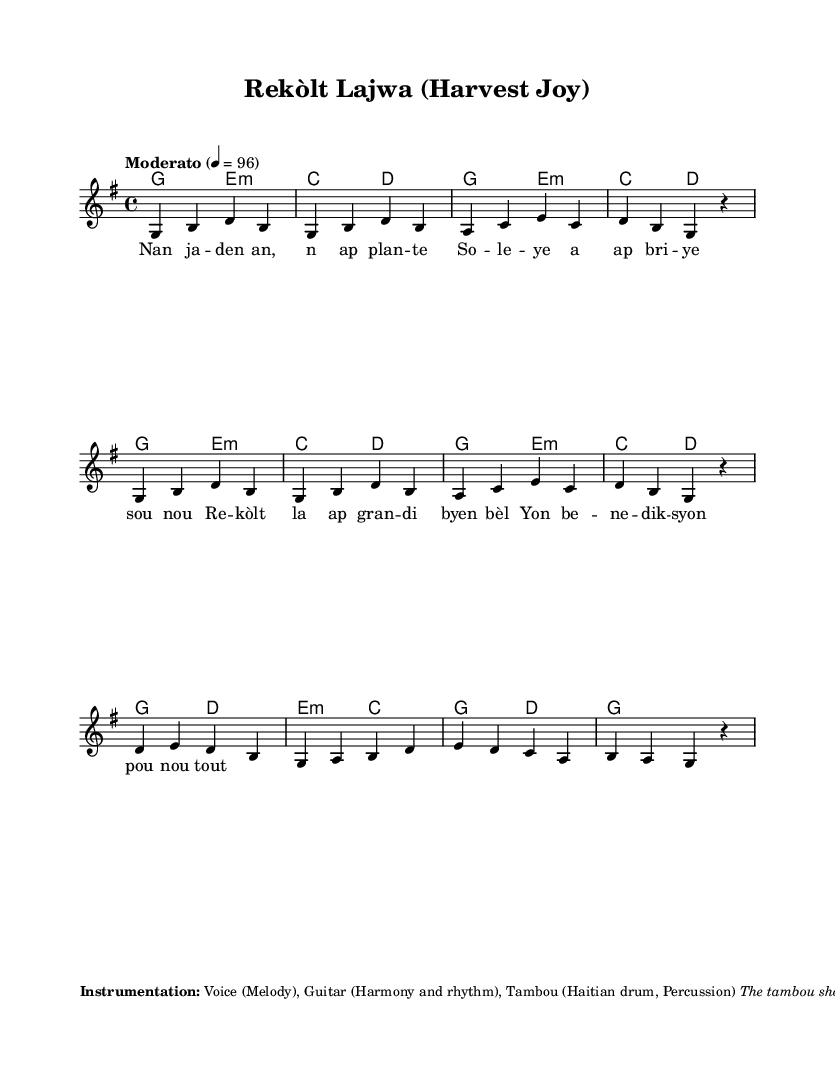What is the key signature of this music? The key signature is G major, which has one sharp (F#). This can be determined from the notation at the beginning of the score.
Answer: G major What is the time signature of this music? The time signature is 4/4, as indicated at the beginning of the score, which means there are four beats per measure.
Answer: 4/4 What is the tempo marking of this piece? The tempo marking is "Moderato," and the metronome mark is 4 = 96, indicating a moderate speed to the piece.
Answer: Moderato How many measures are in the melody? The melody consists of eight measures, which can be counted from the starting point until before the repeat starts. Each line typically contains four measures, and there are two lines in this score.
Answer: 8 What is the primary instrument for the melody in this folk song? The primary instrument for the melody is the voice, which delivers the lyrics and the main theme. This is indicated explicitly in the instrumentation section.
Answer: Voice What rhythmic pattern should the tambou emphasize? The tambou should emphasize the second and fourth beats of each measure, as noted in the instrumentation section of the score. This is typical for Haitian rhythms, adding a lively feel to the music.
Answer: Second and fourth beats 